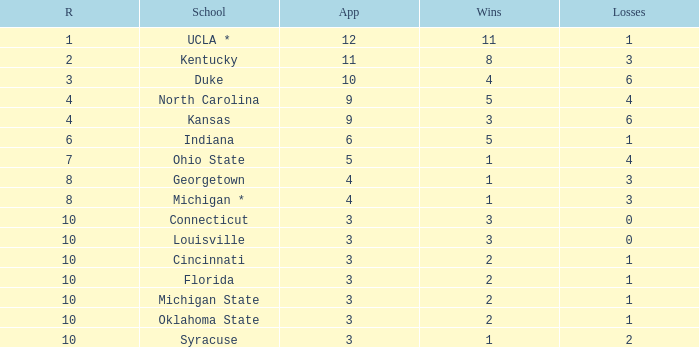Tell me the sum of losses for wins less than 2 and rank of 10 with appearances larger than 3 None. 